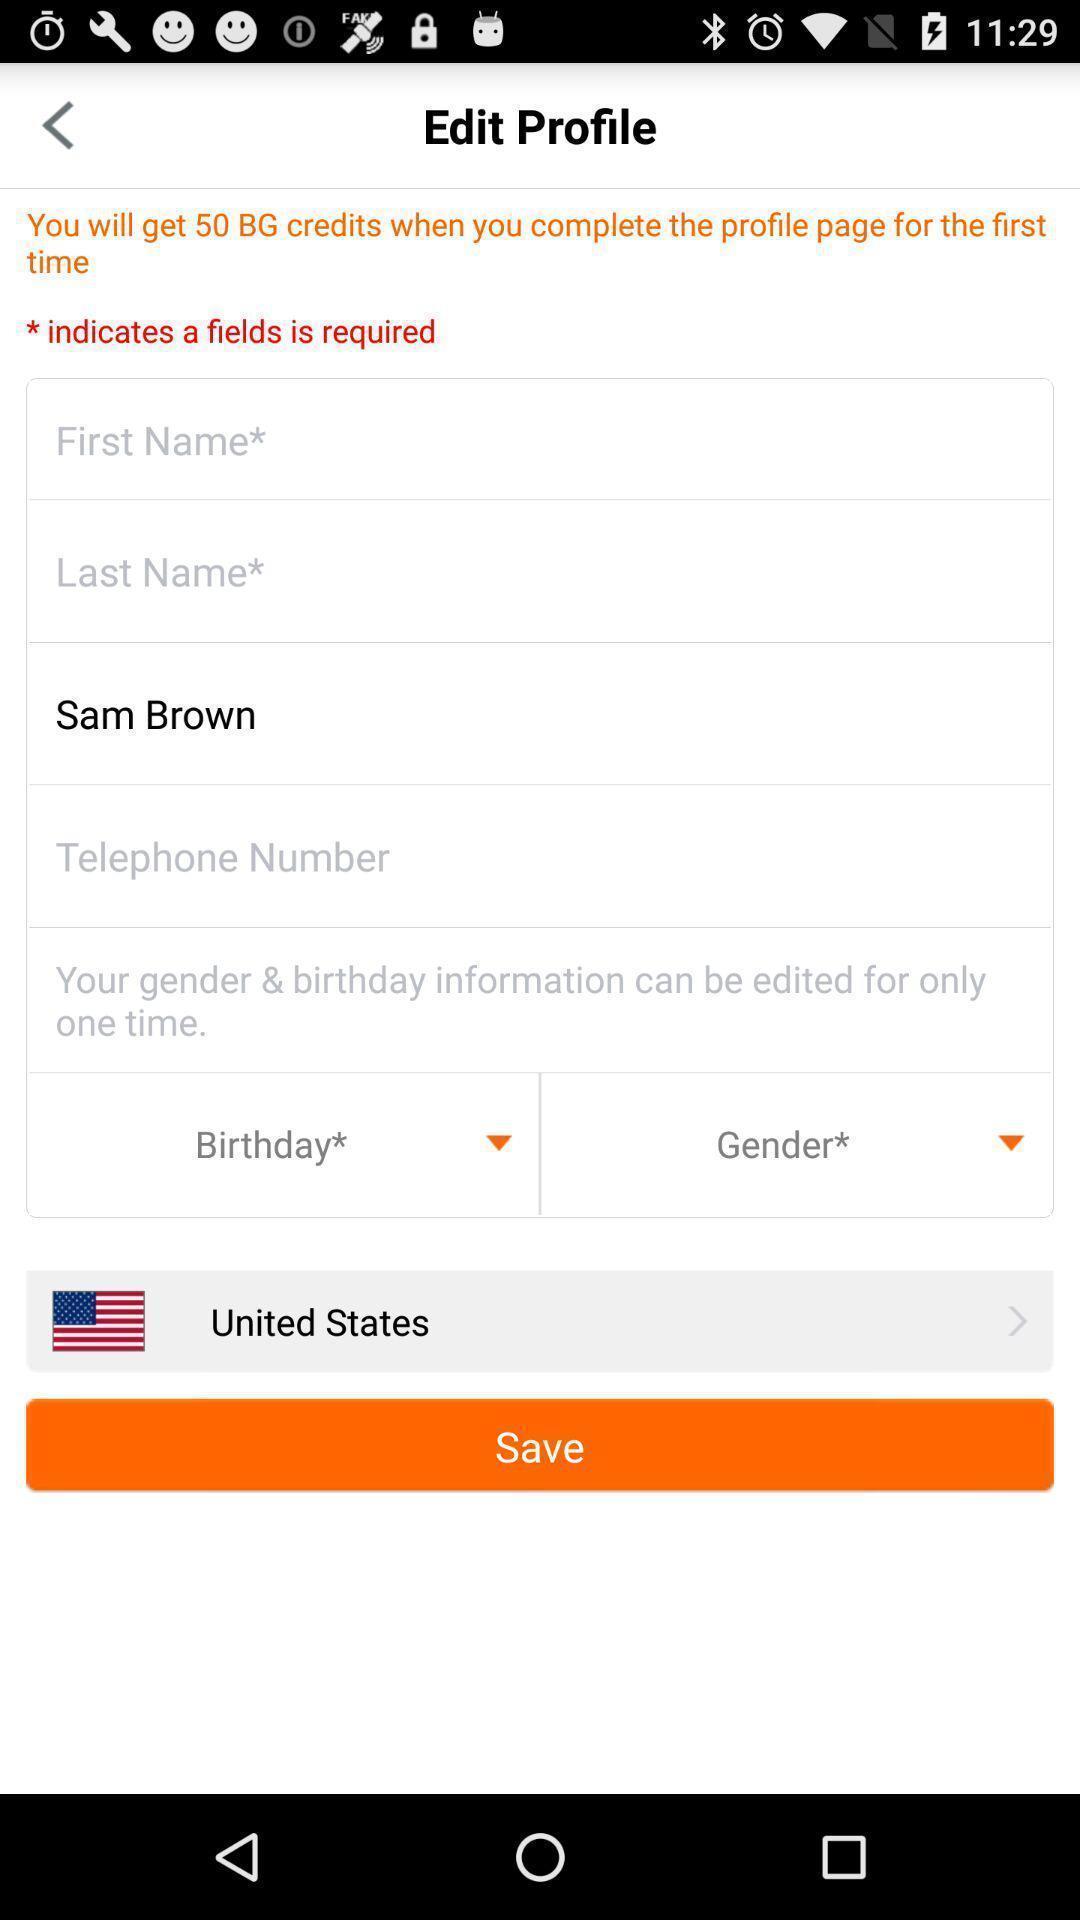Describe the key features of this screenshot. Screen displaying about profile details. 